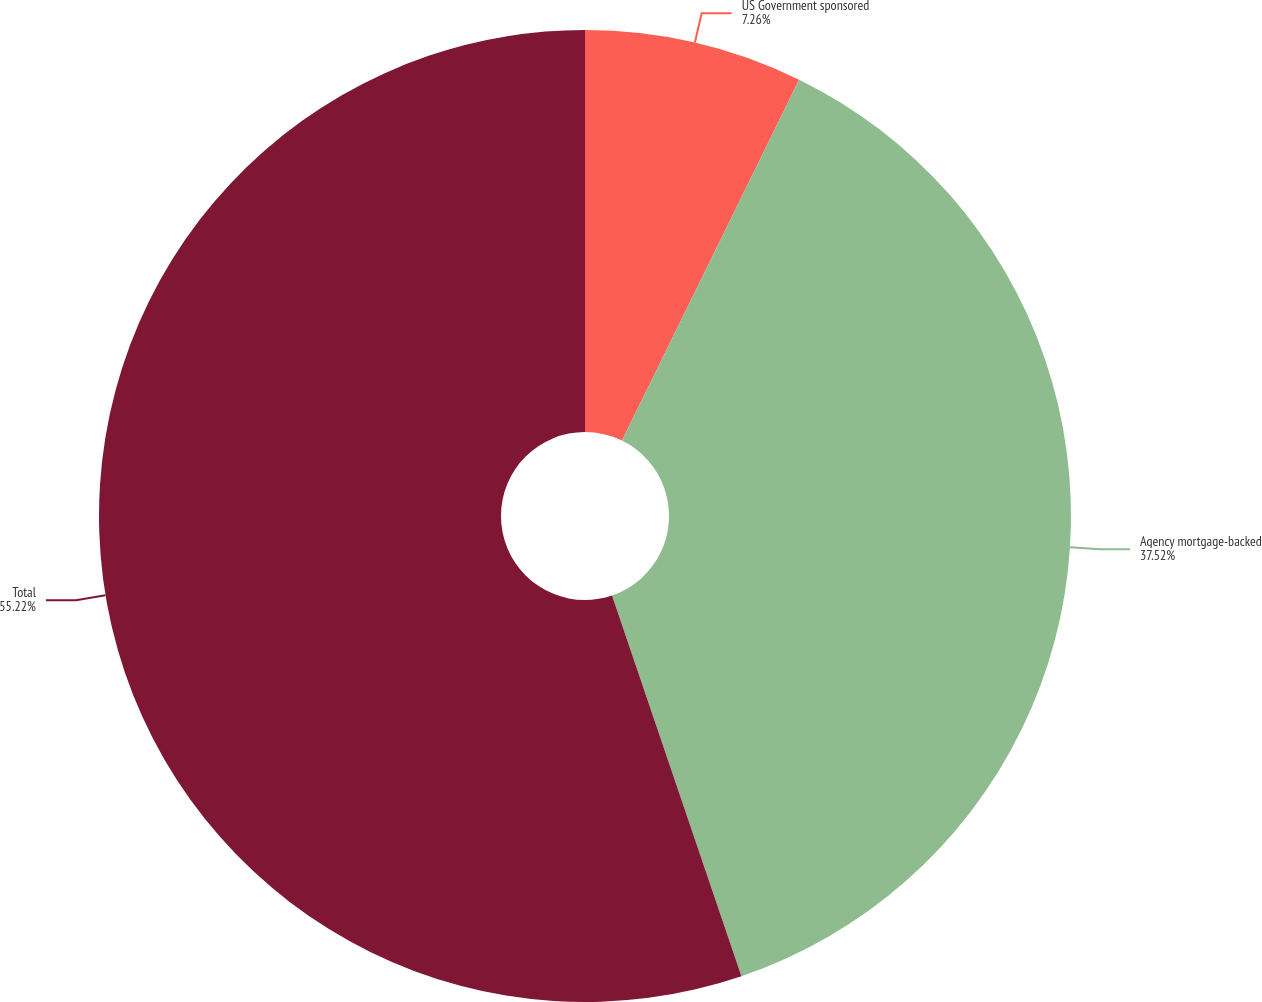<chart> <loc_0><loc_0><loc_500><loc_500><pie_chart><fcel>US Government sponsored<fcel>Agency mortgage-backed<fcel>Total<nl><fcel>7.26%<fcel>37.52%<fcel>55.21%<nl></chart> 